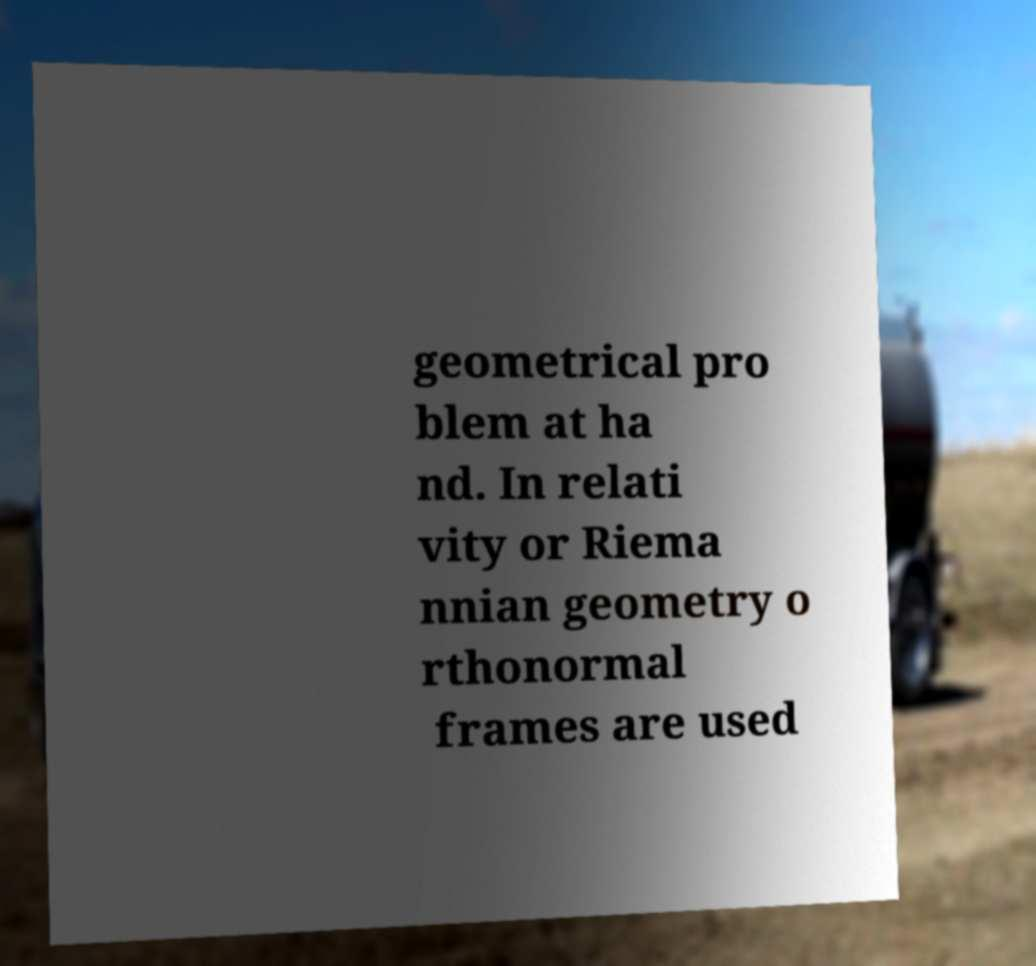Could you assist in decoding the text presented in this image and type it out clearly? geometrical pro blem at ha nd. In relati vity or Riema nnian geometry o rthonormal frames are used 